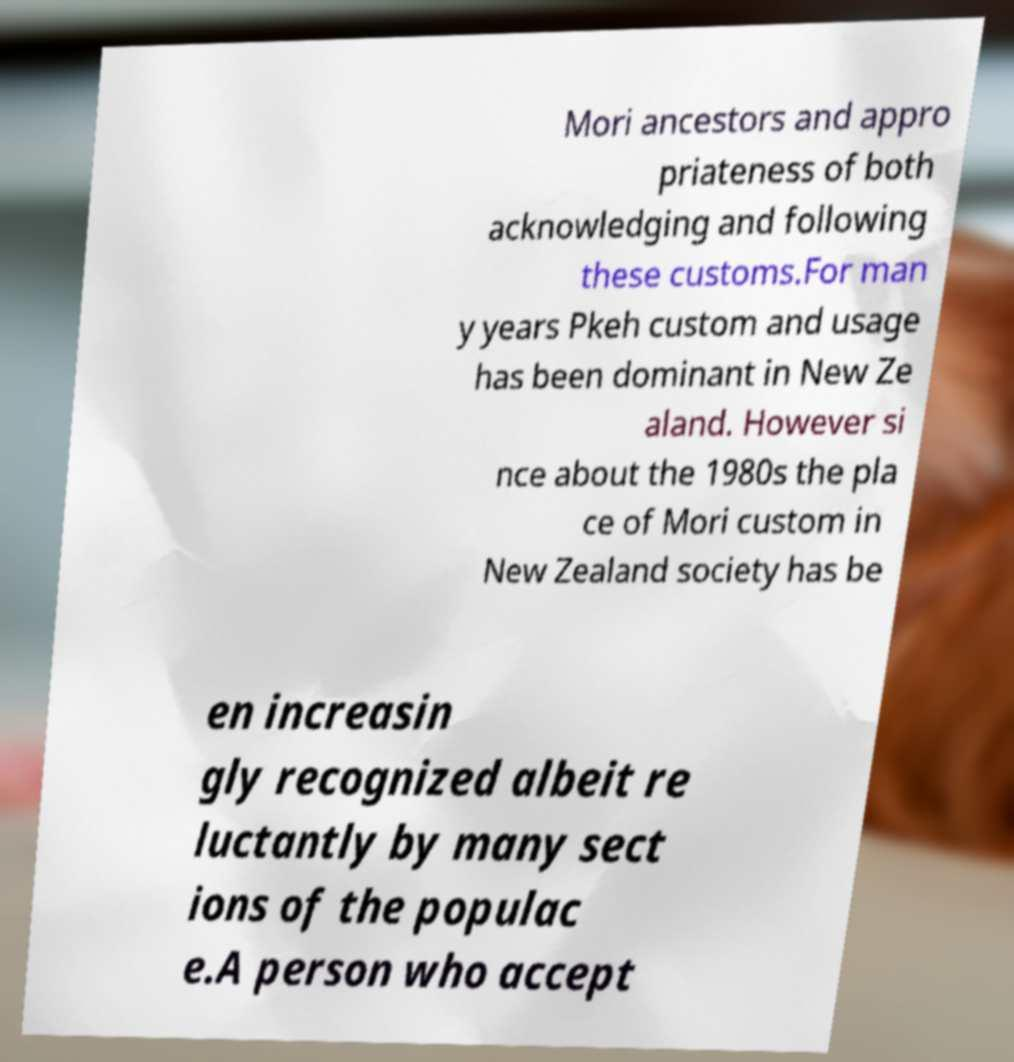Can you accurately transcribe the text from the provided image for me? Mori ancestors and appro priateness of both acknowledging and following these customs.For man y years Pkeh custom and usage has been dominant in New Ze aland. However si nce about the 1980s the pla ce of Mori custom in New Zealand society has be en increasin gly recognized albeit re luctantly by many sect ions of the populac e.A person who accept 